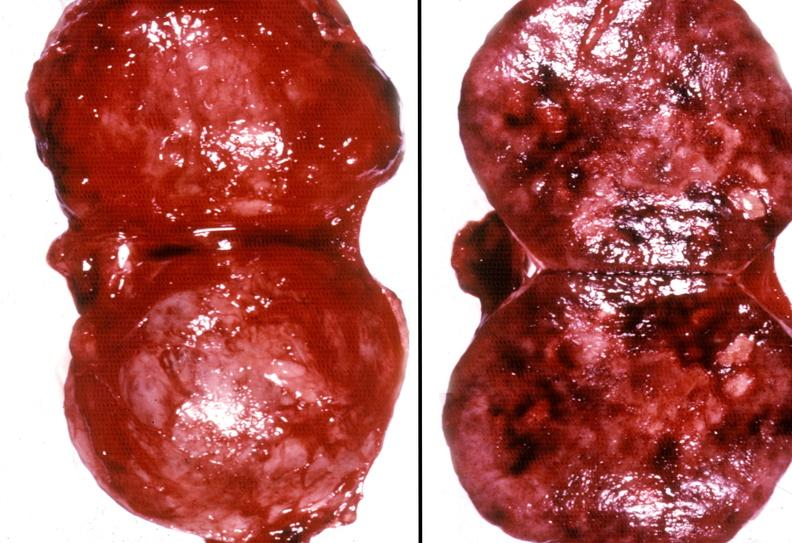what is present?
Answer the question using a single word or phrase. Endocrine 